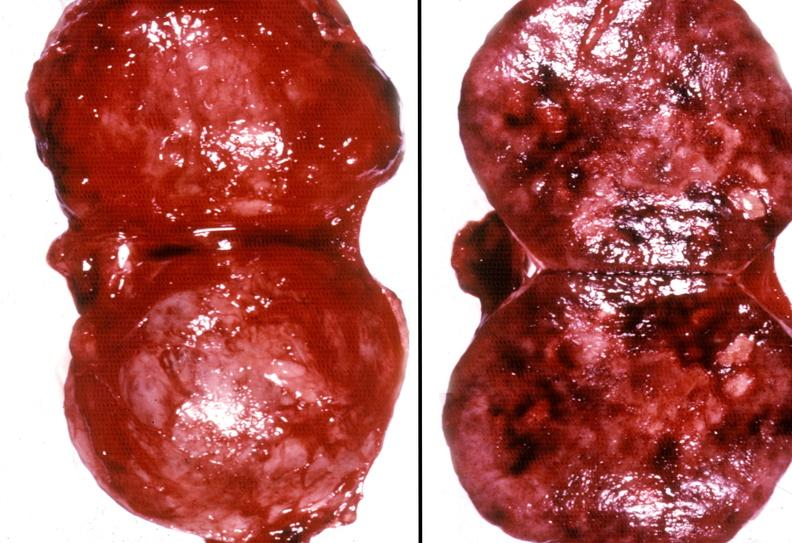what is present?
Answer the question using a single word or phrase. Endocrine 